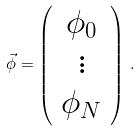<formula> <loc_0><loc_0><loc_500><loc_500>\vec { \phi } = \left ( \begin{array} { c } \phi _ { 0 } \\ \vdots \\ \phi _ { N } \end{array} \right ) \, .</formula> 